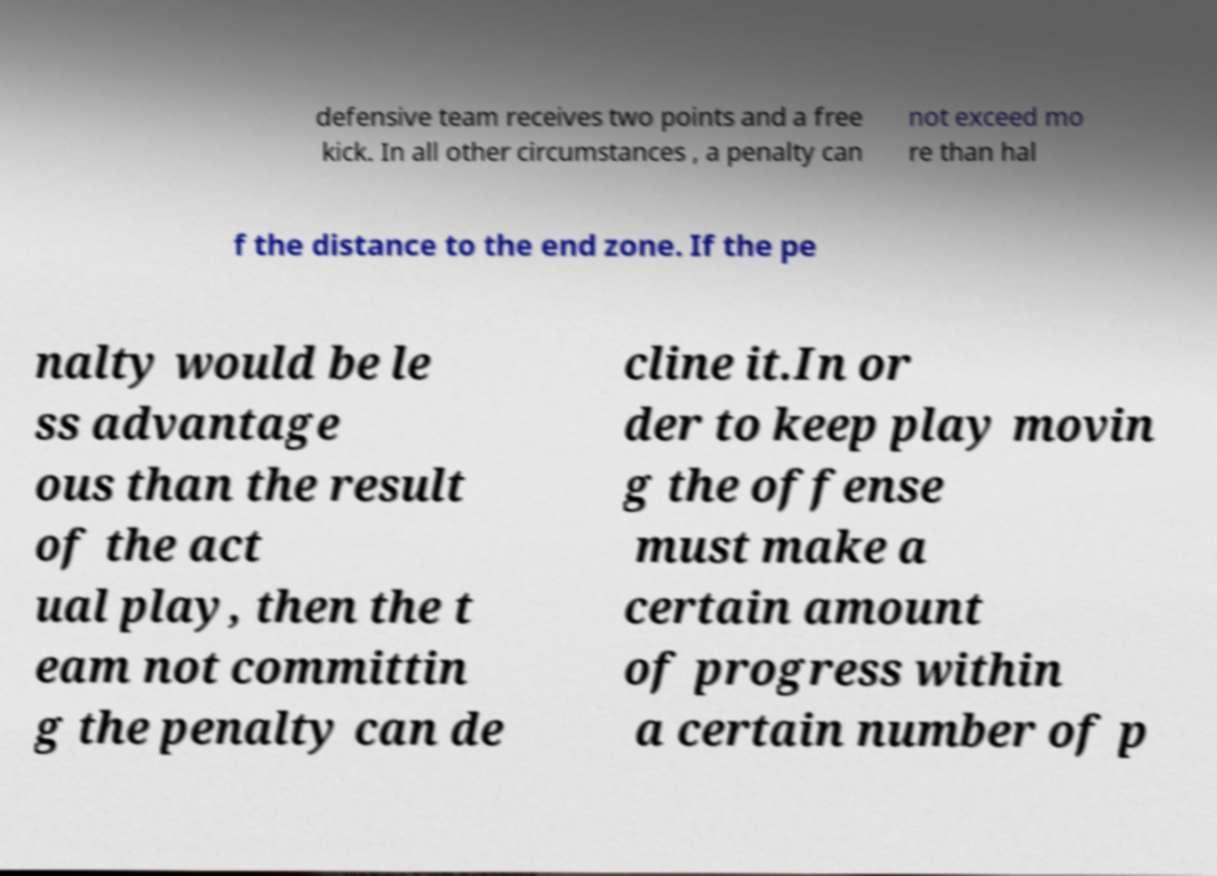What messages or text are displayed in this image? I need them in a readable, typed format. defensive team receives two points and a free kick. In all other circumstances , a penalty can not exceed mo re than hal f the distance to the end zone. If the pe nalty would be le ss advantage ous than the result of the act ual play, then the t eam not committin g the penalty can de cline it.In or der to keep play movin g the offense must make a certain amount of progress within a certain number of p 